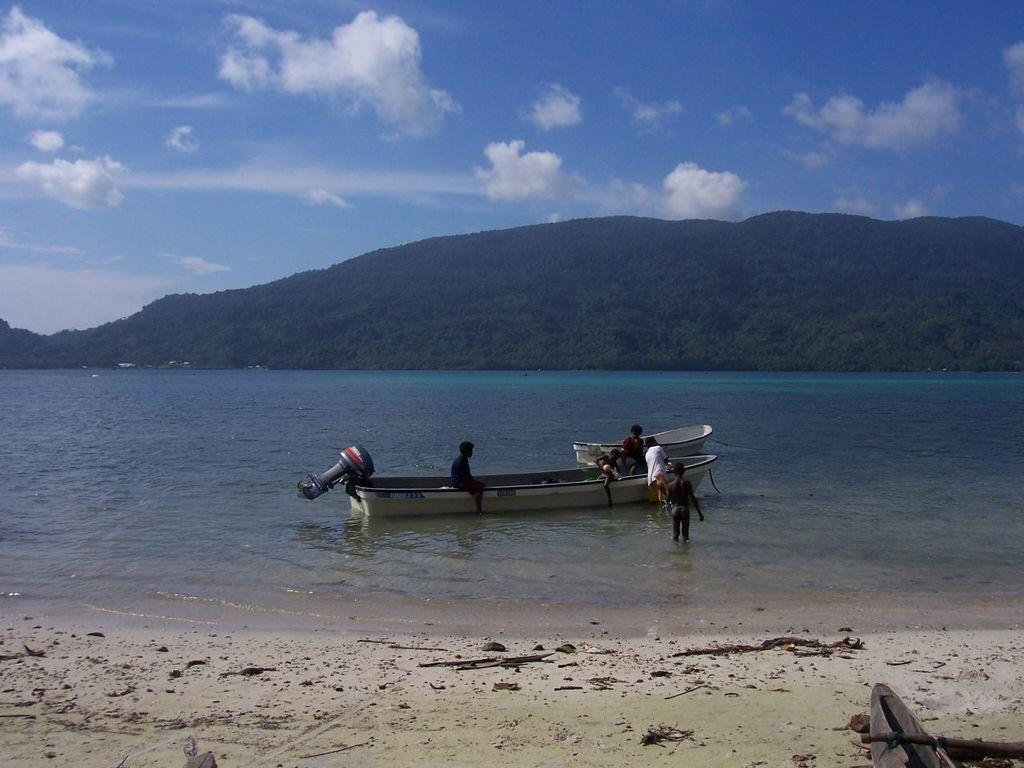What is in the foreground of the image? There is sand in the foreground of the image. What can be seen in the background of the image? There is water, a boat, people on the boat, a cliff, and the sky visible in the background of the image. What is the condition of the sky in the image? The sky is visible in the background of the image, and there are clouds present. Can you tell me how many porters are carrying the chain and pump in the image? There is no chain or pump present in the image, and therefore no porters carrying them. What type of pump is visible in the image? There is no pump present in the image. 